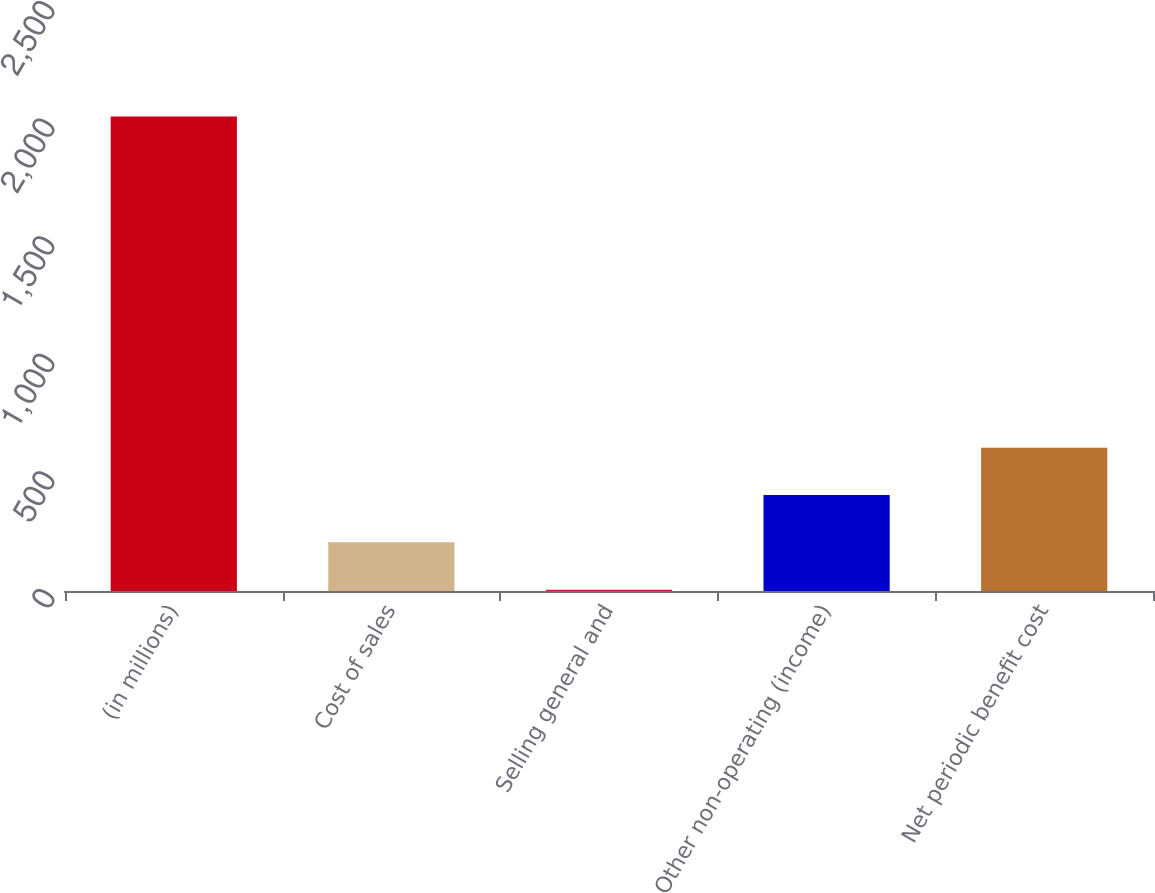Convert chart to OTSL. <chart><loc_0><loc_0><loc_500><loc_500><bar_chart><fcel>(in millions)<fcel>Cost of sales<fcel>Selling general and<fcel>Other non-operating (income)<fcel>Net periodic benefit cost<nl><fcel>2017<fcel>206.92<fcel>5.8<fcel>408.04<fcel>609.16<nl></chart> 